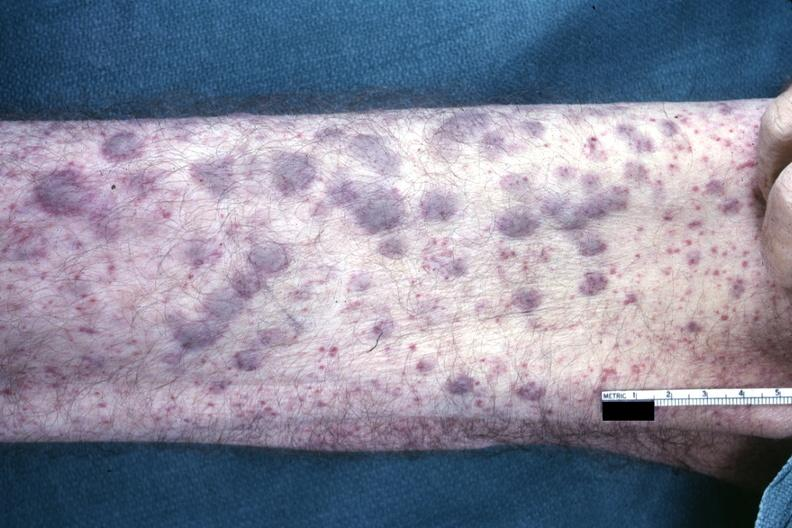s not good color photo showing elevated macular lesions said to be infiltrates of aml?
Answer the question using a single word or phrase. Yes 